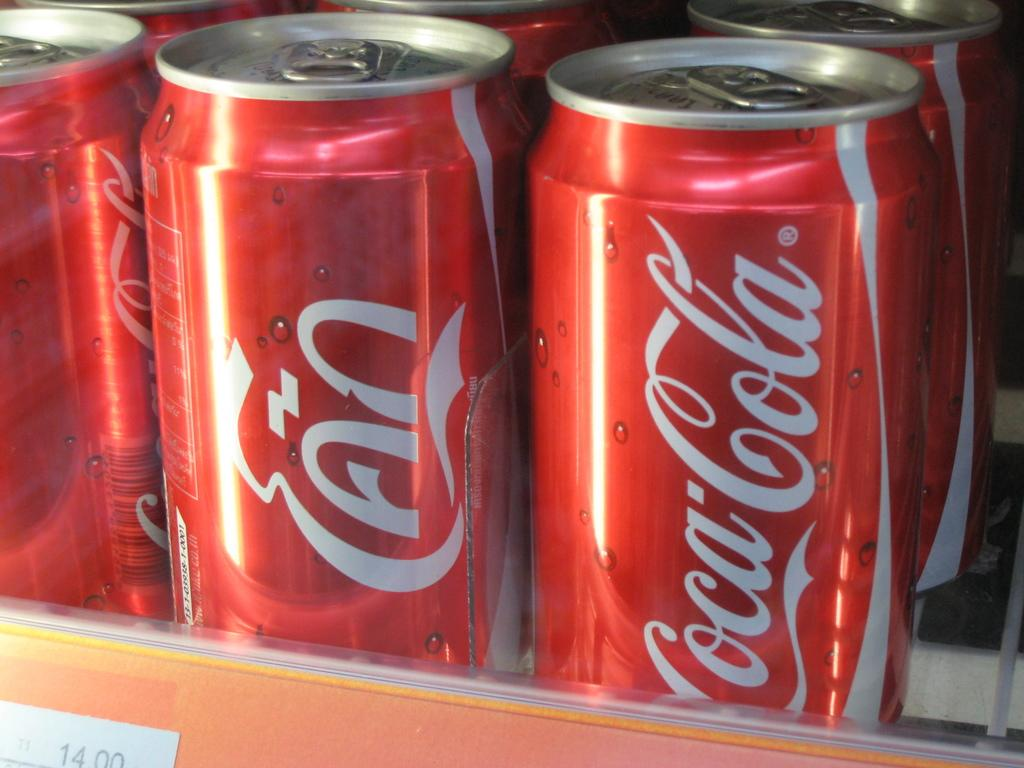<image>
Give a short and clear explanation of the subsequent image. several cans of coca cola are sitting for sale 